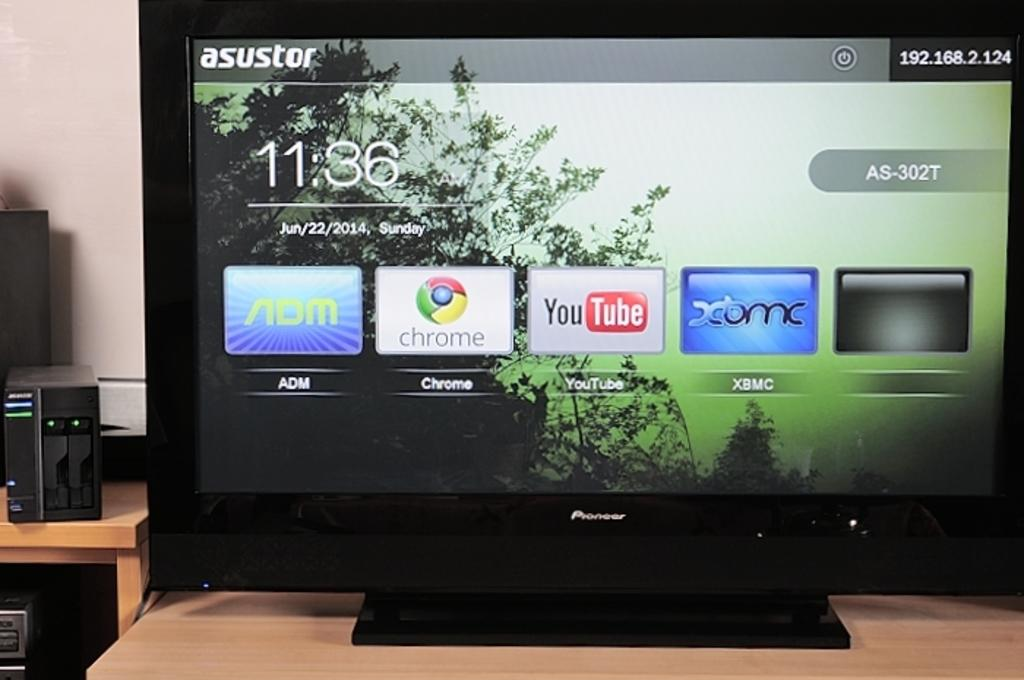<image>
Describe the image concisely. The monitor is displaying the date as Sunday June 22nd, 2014. 